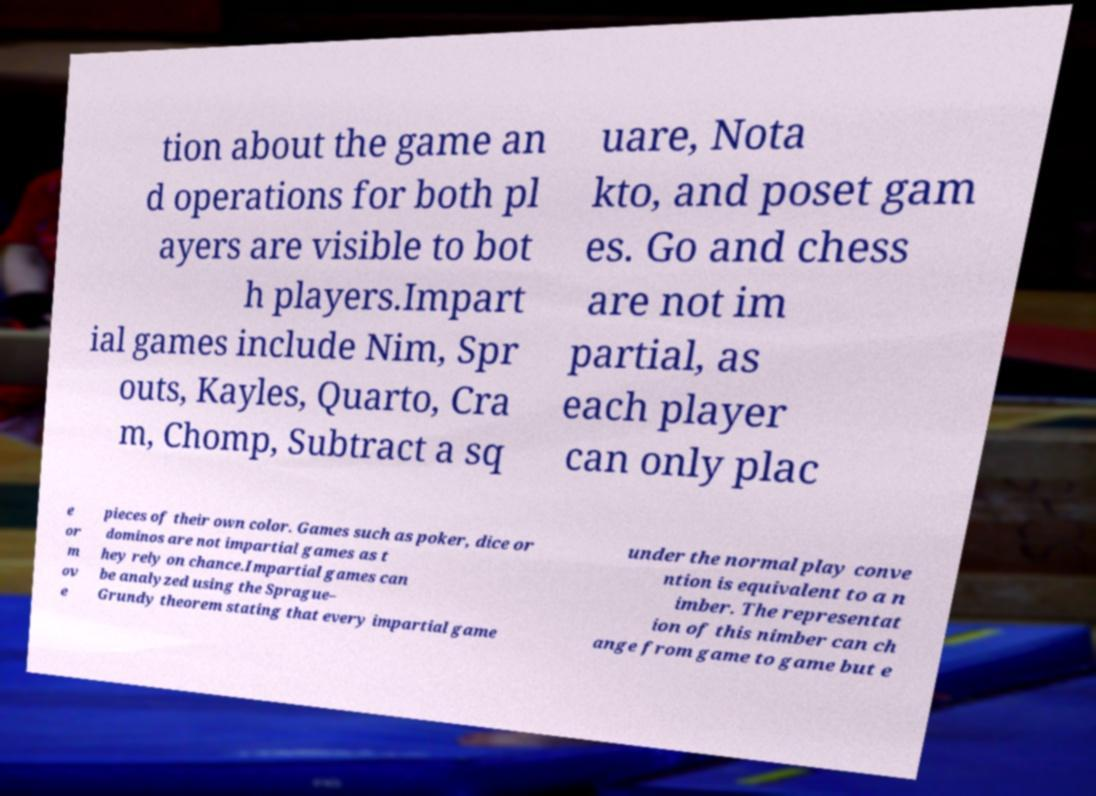What messages or text are displayed in this image? I need them in a readable, typed format. tion about the game an d operations for both pl ayers are visible to bot h players.Impart ial games include Nim, Spr outs, Kayles, Quarto, Cra m, Chomp, Subtract a sq uare, Nota kto, and poset gam es. Go and chess are not im partial, as each player can only plac e or m ov e pieces of their own color. Games such as poker, dice or dominos are not impartial games as t hey rely on chance.Impartial games can be analyzed using the Sprague– Grundy theorem stating that every impartial game under the normal play conve ntion is equivalent to a n imber. The representat ion of this nimber can ch ange from game to game but e 